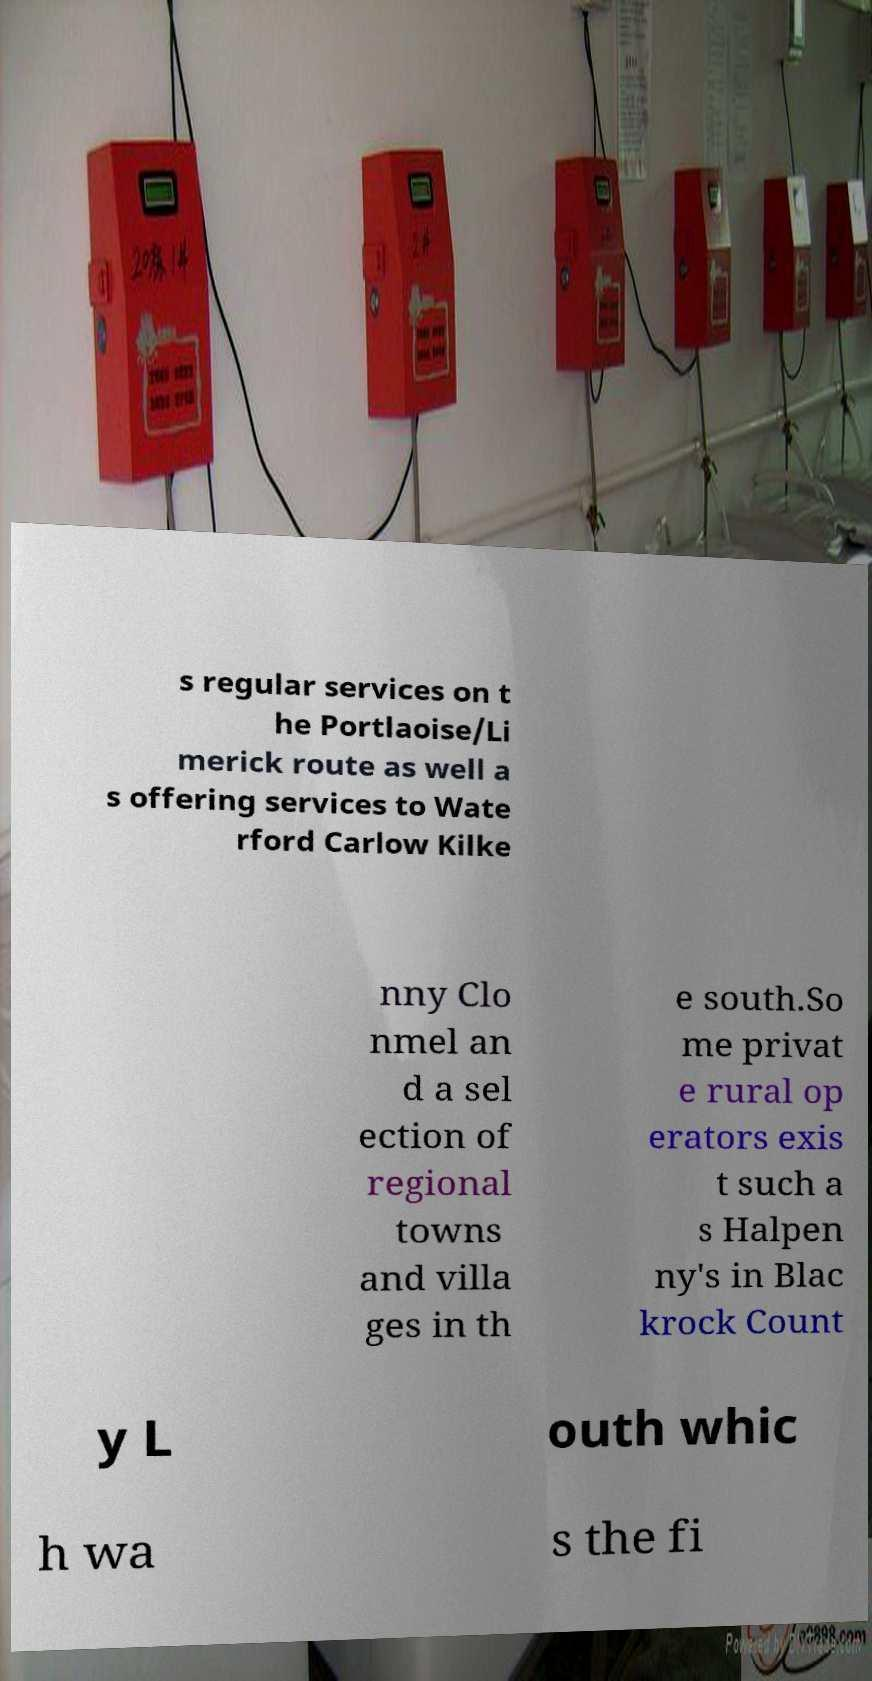Could you extract and type out the text from this image? s regular services on t he Portlaoise/Li merick route as well a s offering services to Wate rford Carlow Kilke nny Clo nmel an d a sel ection of regional towns and villa ges in th e south.So me privat e rural op erators exis t such a s Halpen ny's in Blac krock Count y L outh whic h wa s the fi 